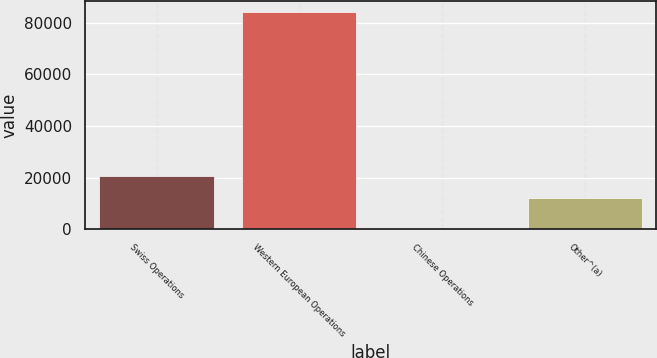Convert chart to OTSL. <chart><loc_0><loc_0><loc_500><loc_500><bar_chart><fcel>Swiss Operations<fcel>Western European Operations<fcel>Chinese Operations<fcel>Other^(a)<nl><fcel>20599.1<fcel>84118<fcel>647<fcel>12252<nl></chart> 